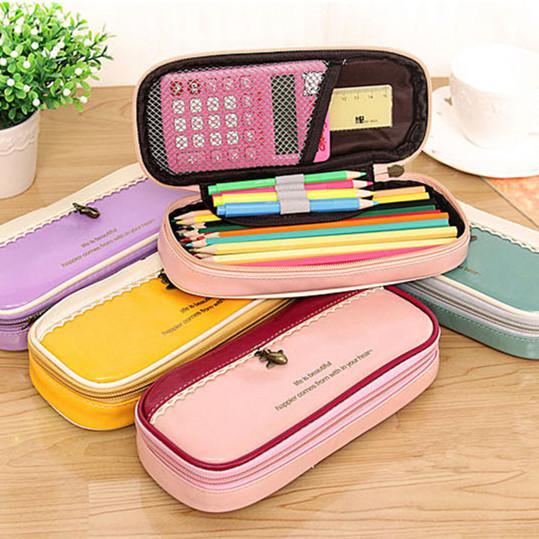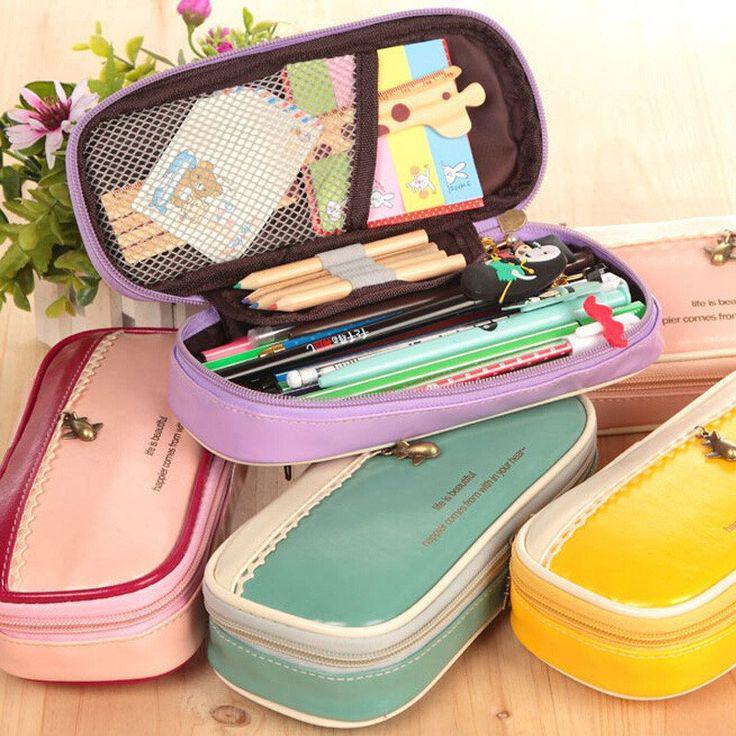The first image is the image on the left, the second image is the image on the right. Examine the images to the left and right. Is the description "The open pouch in one of the images contains an electronic device." accurate? Answer yes or no. Yes. 